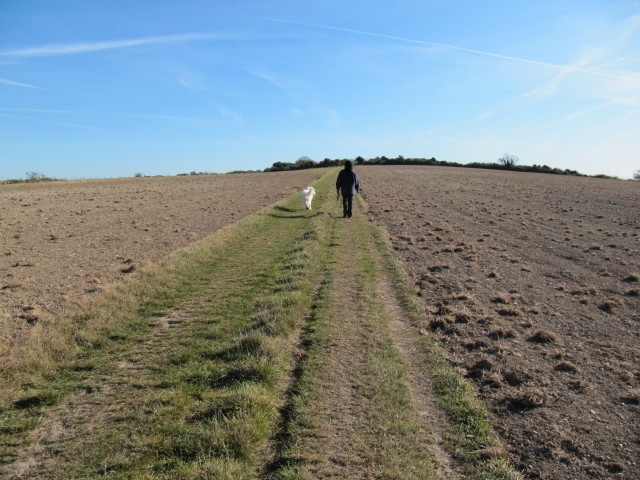Describe the objects in this image and their specific colors. I can see people in gray and black tones and dog in gray, lightgray, and darkgray tones in this image. 